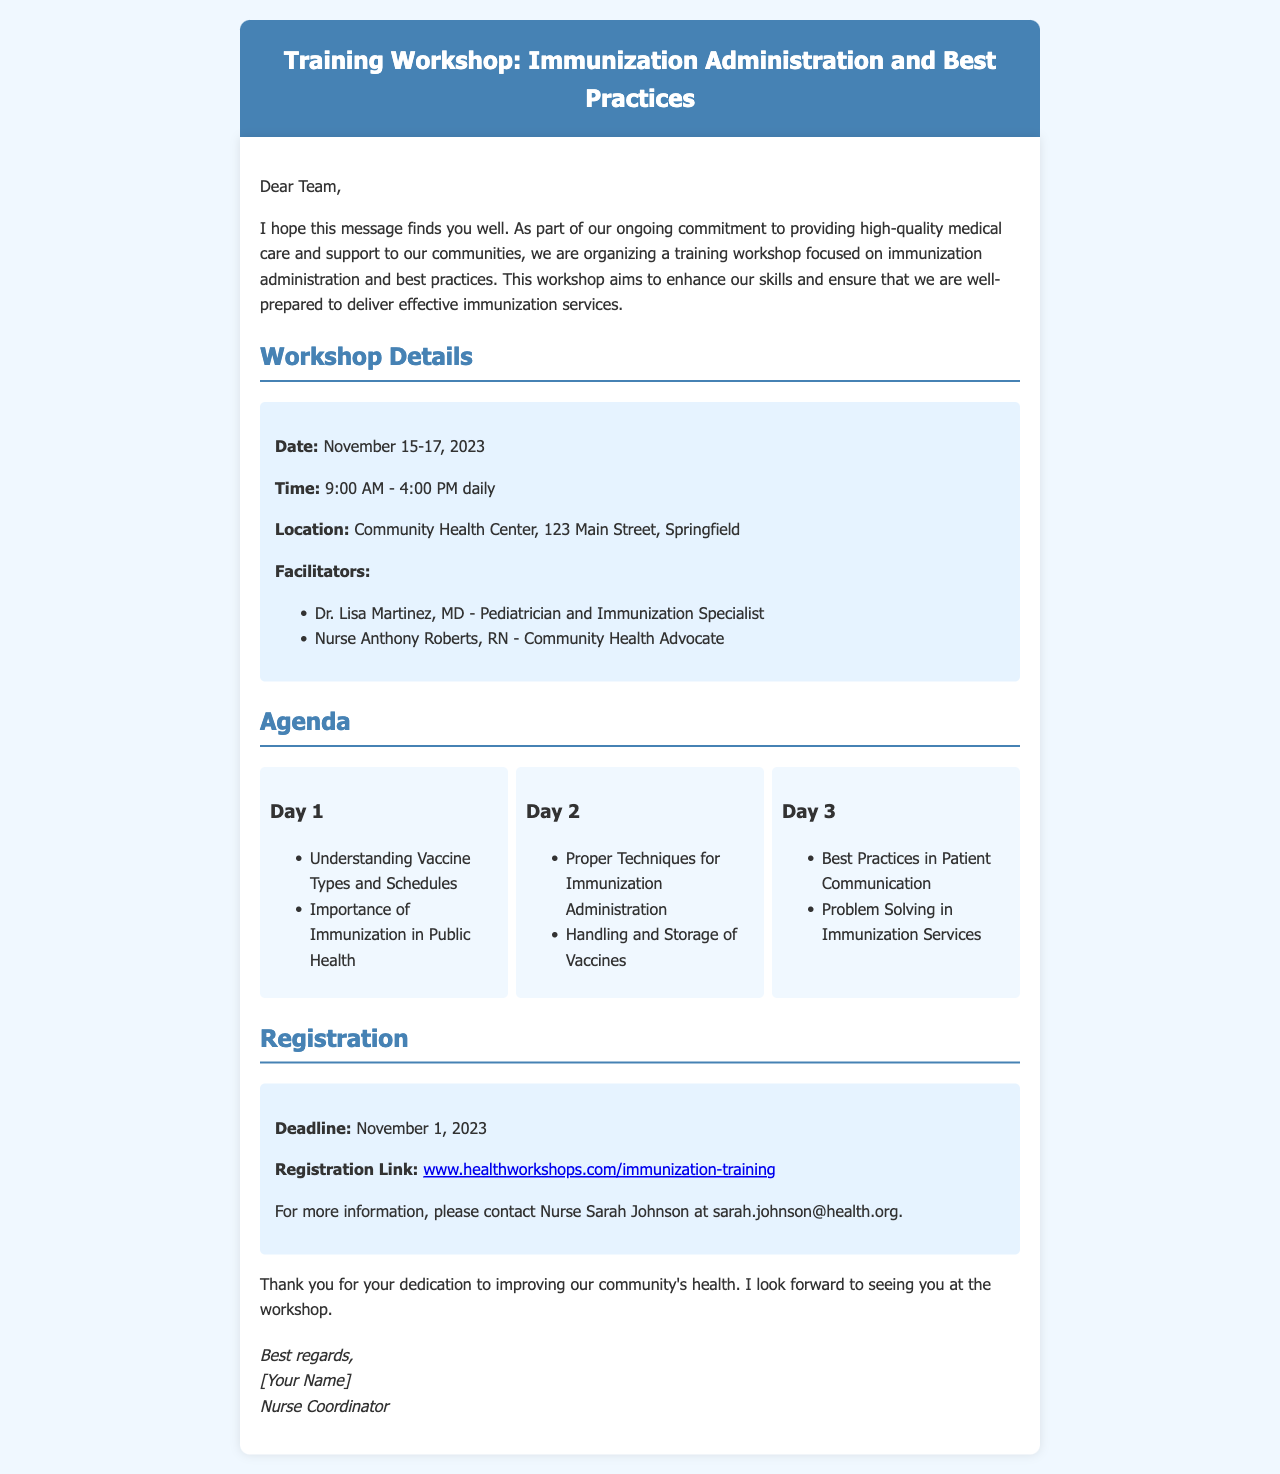What are the dates of the workshop? The workshop is scheduled for November 15-17, 2023, as mentioned in the workshop details section.
Answer: November 15-17, 2023 What time does the workshop start daily? The daily start time for the workshop is provided in the workshop details section as 9:00 AM.
Answer: 9:00 AM Where is the workshop located? The location of the workshop is specifically noted in the workshop details, which is the Community Health Center, 123 Main Street, Springfield.
Answer: Community Health Center, 123 Main Street, Springfield Who is one of the facilitators? The document lists facilitators in the workshop details section; one of them is Dr. Lisa Martinez, MD.
Answer: Dr. Lisa Martinez, MD What is the deadline for registration? The registration deadline is specified in the registration section as November 1, 2023.
Answer: November 1, 2023 Which day covers vaccine types and schedules? The agenda lists vaccine types and schedules under Day 1's activities on the first day of the workshop.
Answer: Day 1 What topic is covered on Day 3? The agenda mentions "Best Practices in Patient Communication" as one of the topics for Day 3.
Answer: Best Practices in Patient Communication How can participants register for the workshop? The registration link is provided in the registration section as part of the process to register for the workshop.
Answer: www.healthworkshops.com/immunization-training Who should participants contact for more information? The document mentions Nurse Sarah Johnson's contact information for inquiries about the workshop.
Answer: Nurse Sarah Johnson 